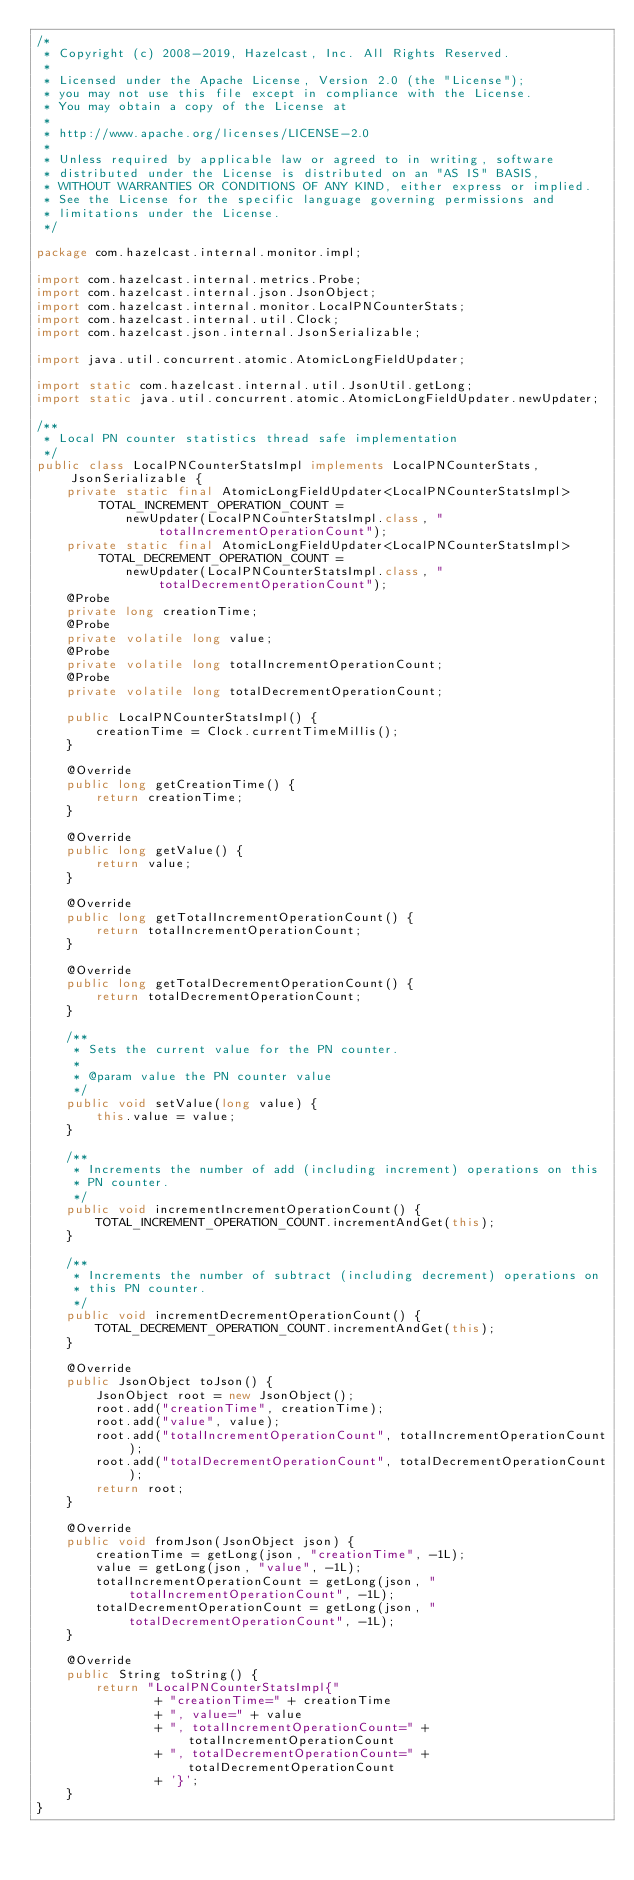Convert code to text. <code><loc_0><loc_0><loc_500><loc_500><_Java_>/*
 * Copyright (c) 2008-2019, Hazelcast, Inc. All Rights Reserved.
 *
 * Licensed under the Apache License, Version 2.0 (the "License");
 * you may not use this file except in compliance with the License.
 * You may obtain a copy of the License at
 *
 * http://www.apache.org/licenses/LICENSE-2.0
 *
 * Unless required by applicable law or agreed to in writing, software
 * distributed under the License is distributed on an "AS IS" BASIS,
 * WITHOUT WARRANTIES OR CONDITIONS OF ANY KIND, either express or implied.
 * See the License for the specific language governing permissions and
 * limitations under the License.
 */

package com.hazelcast.internal.monitor.impl;

import com.hazelcast.internal.metrics.Probe;
import com.hazelcast.internal.json.JsonObject;
import com.hazelcast.internal.monitor.LocalPNCounterStats;
import com.hazelcast.internal.util.Clock;
import com.hazelcast.json.internal.JsonSerializable;

import java.util.concurrent.atomic.AtomicLongFieldUpdater;

import static com.hazelcast.internal.util.JsonUtil.getLong;
import static java.util.concurrent.atomic.AtomicLongFieldUpdater.newUpdater;

/**
 * Local PN counter statistics thread safe implementation
 */
public class LocalPNCounterStatsImpl implements LocalPNCounterStats, JsonSerializable {
    private static final AtomicLongFieldUpdater<LocalPNCounterStatsImpl> TOTAL_INCREMENT_OPERATION_COUNT =
            newUpdater(LocalPNCounterStatsImpl.class, "totalIncrementOperationCount");
    private static final AtomicLongFieldUpdater<LocalPNCounterStatsImpl> TOTAL_DECREMENT_OPERATION_COUNT =
            newUpdater(LocalPNCounterStatsImpl.class, "totalDecrementOperationCount");
    @Probe
    private long creationTime;
    @Probe
    private volatile long value;
    @Probe
    private volatile long totalIncrementOperationCount;
    @Probe
    private volatile long totalDecrementOperationCount;

    public LocalPNCounterStatsImpl() {
        creationTime = Clock.currentTimeMillis();
    }

    @Override
    public long getCreationTime() {
        return creationTime;
    }

    @Override
    public long getValue() {
        return value;
    }

    @Override
    public long getTotalIncrementOperationCount() {
        return totalIncrementOperationCount;
    }

    @Override
    public long getTotalDecrementOperationCount() {
        return totalDecrementOperationCount;
    }

    /**
     * Sets the current value for the PN counter.
     *
     * @param value the PN counter value
     */
    public void setValue(long value) {
        this.value = value;
    }

    /**
     * Increments the number of add (including increment) operations on this
     * PN counter.
     */
    public void incrementIncrementOperationCount() {
        TOTAL_INCREMENT_OPERATION_COUNT.incrementAndGet(this);
    }

    /**
     * Increments the number of subtract (including decrement) operations on
     * this PN counter.
     */
    public void incrementDecrementOperationCount() {
        TOTAL_DECREMENT_OPERATION_COUNT.incrementAndGet(this);
    }

    @Override
    public JsonObject toJson() {
        JsonObject root = new JsonObject();
        root.add("creationTime", creationTime);
        root.add("value", value);
        root.add("totalIncrementOperationCount", totalIncrementOperationCount);
        root.add("totalDecrementOperationCount", totalDecrementOperationCount);
        return root;
    }

    @Override
    public void fromJson(JsonObject json) {
        creationTime = getLong(json, "creationTime", -1L);
        value = getLong(json, "value", -1L);
        totalIncrementOperationCount = getLong(json, "totalIncrementOperationCount", -1L);
        totalDecrementOperationCount = getLong(json, "totalDecrementOperationCount", -1L);
    }

    @Override
    public String toString() {
        return "LocalPNCounterStatsImpl{"
                + "creationTime=" + creationTime
                + ", value=" + value
                + ", totalIncrementOperationCount=" + totalIncrementOperationCount
                + ", totalDecrementOperationCount=" + totalDecrementOperationCount
                + '}';
    }
}
</code> 